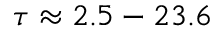Convert formula to latex. <formula><loc_0><loc_0><loc_500><loc_500>\tau \approx 2 . 5 - 2 3 . 6</formula> 